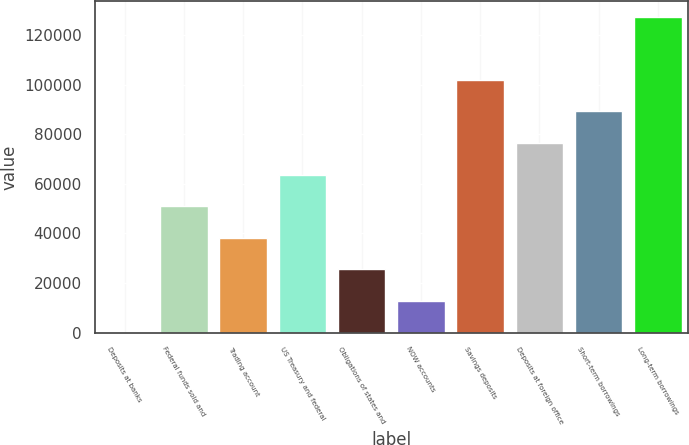Convert chart. <chart><loc_0><loc_0><loc_500><loc_500><bar_chart><fcel>Deposits at banks<fcel>Federal funds sold and<fcel>Trading account<fcel>US Treasury and federal<fcel>Obligations of states and<fcel>NOW accounts<fcel>Savings deposits<fcel>Deposits at foreign office<fcel>Short-term borrowings<fcel>Long-term borrowings<nl><fcel>72<fcel>50980<fcel>38253<fcel>63707<fcel>25526<fcel>12799<fcel>101888<fcel>76434<fcel>89161<fcel>127342<nl></chart> 